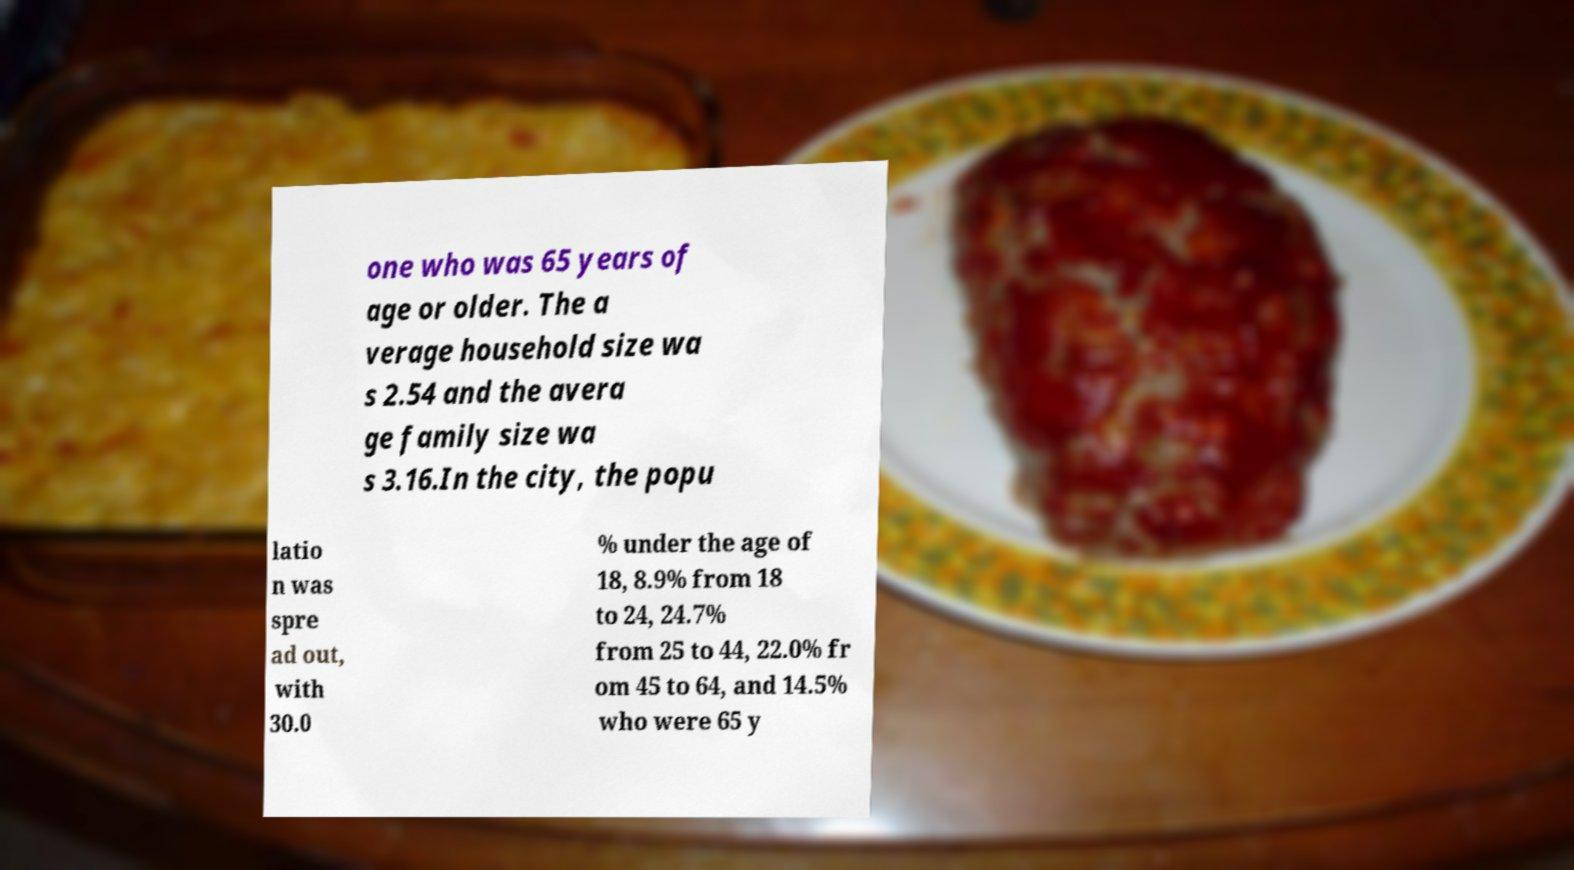Please identify and transcribe the text found in this image. one who was 65 years of age or older. The a verage household size wa s 2.54 and the avera ge family size wa s 3.16.In the city, the popu latio n was spre ad out, with 30.0 % under the age of 18, 8.9% from 18 to 24, 24.7% from 25 to 44, 22.0% fr om 45 to 64, and 14.5% who were 65 y 